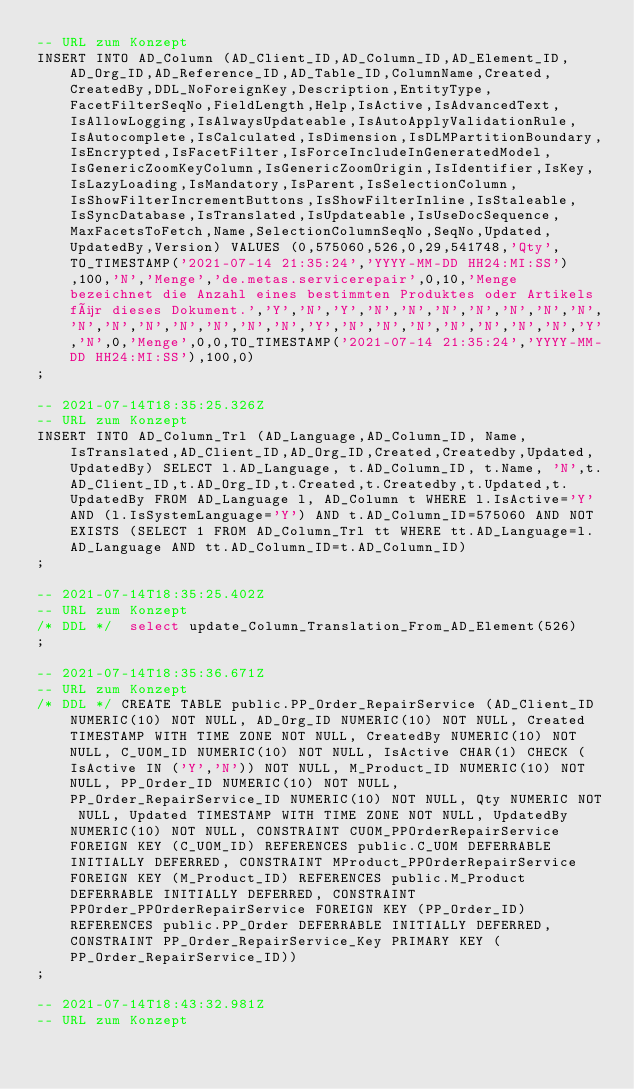Convert code to text. <code><loc_0><loc_0><loc_500><loc_500><_SQL_>-- URL zum Konzept
INSERT INTO AD_Column (AD_Client_ID,AD_Column_ID,AD_Element_ID,AD_Org_ID,AD_Reference_ID,AD_Table_ID,ColumnName,Created,CreatedBy,DDL_NoForeignKey,Description,EntityType,FacetFilterSeqNo,FieldLength,Help,IsActive,IsAdvancedText,IsAllowLogging,IsAlwaysUpdateable,IsAutoApplyValidationRule,IsAutocomplete,IsCalculated,IsDimension,IsDLMPartitionBoundary,IsEncrypted,IsFacetFilter,IsForceIncludeInGeneratedModel,IsGenericZoomKeyColumn,IsGenericZoomOrigin,IsIdentifier,IsKey,IsLazyLoading,IsMandatory,IsParent,IsSelectionColumn,IsShowFilterIncrementButtons,IsShowFilterInline,IsStaleable,IsSyncDatabase,IsTranslated,IsUpdateable,IsUseDocSequence,MaxFacetsToFetch,Name,SelectionColumnSeqNo,SeqNo,Updated,UpdatedBy,Version) VALUES (0,575060,526,0,29,541748,'Qty',TO_TIMESTAMP('2021-07-14 21:35:24','YYYY-MM-DD HH24:MI:SS'),100,'N','Menge','de.metas.servicerepair',0,10,'Menge bezeichnet die Anzahl eines bestimmten Produktes oder Artikels für dieses Dokument.','Y','N','Y','N','N','N','N','N','N','N','N','N','N','N','N','N','N','Y','N','N','N','N','N','N','N','Y','N',0,'Menge',0,0,TO_TIMESTAMP('2021-07-14 21:35:24','YYYY-MM-DD HH24:MI:SS'),100,0)
;

-- 2021-07-14T18:35:25.326Z
-- URL zum Konzept
INSERT INTO AD_Column_Trl (AD_Language,AD_Column_ID, Name, IsTranslated,AD_Client_ID,AD_Org_ID,Created,Createdby,Updated,UpdatedBy) SELECT l.AD_Language, t.AD_Column_ID, t.Name, 'N',t.AD_Client_ID,t.AD_Org_ID,t.Created,t.Createdby,t.Updated,t.UpdatedBy FROM AD_Language l, AD_Column t WHERE l.IsActive='Y'AND (l.IsSystemLanguage='Y') AND t.AD_Column_ID=575060 AND NOT EXISTS (SELECT 1 FROM AD_Column_Trl tt WHERE tt.AD_Language=l.AD_Language AND tt.AD_Column_ID=t.AD_Column_ID)
;

-- 2021-07-14T18:35:25.402Z
-- URL zum Konzept
/* DDL */  select update_Column_Translation_From_AD_Element(526) 
;

-- 2021-07-14T18:35:36.671Z
-- URL zum Konzept
/* DDL */ CREATE TABLE public.PP_Order_RepairService (AD_Client_ID NUMERIC(10) NOT NULL, AD_Org_ID NUMERIC(10) NOT NULL, Created TIMESTAMP WITH TIME ZONE NOT NULL, CreatedBy NUMERIC(10) NOT NULL, C_UOM_ID NUMERIC(10) NOT NULL, IsActive CHAR(1) CHECK (IsActive IN ('Y','N')) NOT NULL, M_Product_ID NUMERIC(10) NOT NULL, PP_Order_ID NUMERIC(10) NOT NULL, PP_Order_RepairService_ID NUMERIC(10) NOT NULL, Qty NUMERIC NOT NULL, Updated TIMESTAMP WITH TIME ZONE NOT NULL, UpdatedBy NUMERIC(10) NOT NULL, CONSTRAINT CUOM_PPOrderRepairService FOREIGN KEY (C_UOM_ID) REFERENCES public.C_UOM DEFERRABLE INITIALLY DEFERRED, CONSTRAINT MProduct_PPOrderRepairService FOREIGN KEY (M_Product_ID) REFERENCES public.M_Product DEFERRABLE INITIALLY DEFERRED, CONSTRAINT PPOrder_PPOrderRepairService FOREIGN KEY (PP_Order_ID) REFERENCES public.PP_Order DEFERRABLE INITIALLY DEFERRED, CONSTRAINT PP_Order_RepairService_Key PRIMARY KEY (PP_Order_RepairService_ID))
;

-- 2021-07-14T18:43:32.981Z
-- URL zum Konzept</code> 